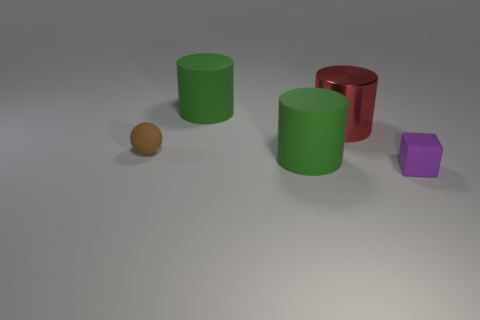Subtract all green rubber cylinders. How many cylinders are left? 1 Subtract all purple spheres. How many green cylinders are left? 2 Add 1 tiny gray shiny things. How many objects exist? 6 Subtract all balls. How many objects are left? 4 Subtract all cyan cylinders. Subtract all green spheres. How many cylinders are left? 3 Subtract all big green rubber things. Subtract all cylinders. How many objects are left? 0 Add 3 big metallic objects. How many big metallic objects are left? 4 Add 4 green cylinders. How many green cylinders exist? 6 Subtract 0 blue balls. How many objects are left? 5 